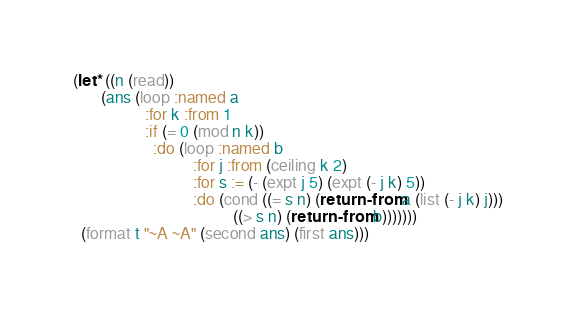<code> <loc_0><loc_0><loc_500><loc_500><_Lisp_>(let* ((n (read))
       (ans (loop :named a
                  :for k :from 1
                  :if (= 0 (mod n k))
                    :do (loop :named b
                              :for j :from (ceiling k 2)
                              :for s := (- (expt j 5) (expt (- j k) 5))
                              :do (cond ((= s n) (return-from a (list (- j k) j)))
                                        ((> s n) (return-from b)))))))
  (format t "~A ~A" (second ans) (first ans)))</code> 